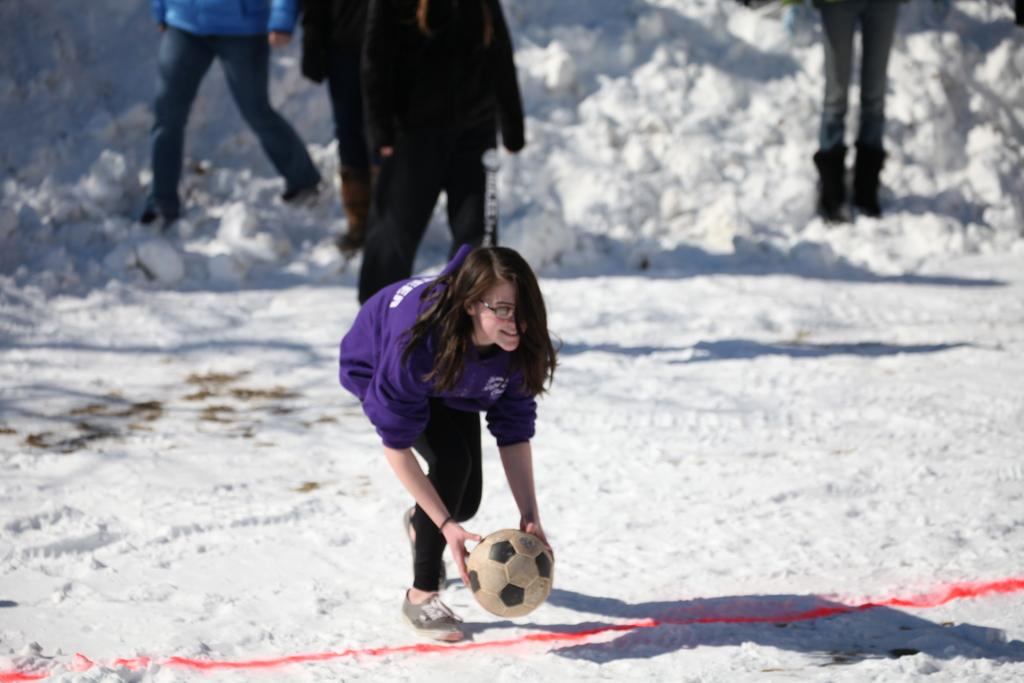Who is the main subject in the image? There is a woman in the image. What is the woman holding in the image? The woman is holding a football. Can you describe the people behind the woman? There is a group of people standing behind the woman. What is the setting of the image? The image depicts a snowy environment. What type of minister is present in the image? There is no minister present in the image. How are the waves affecting the football in the image? There are no waves present in the image; it takes place in a snowy environment. 